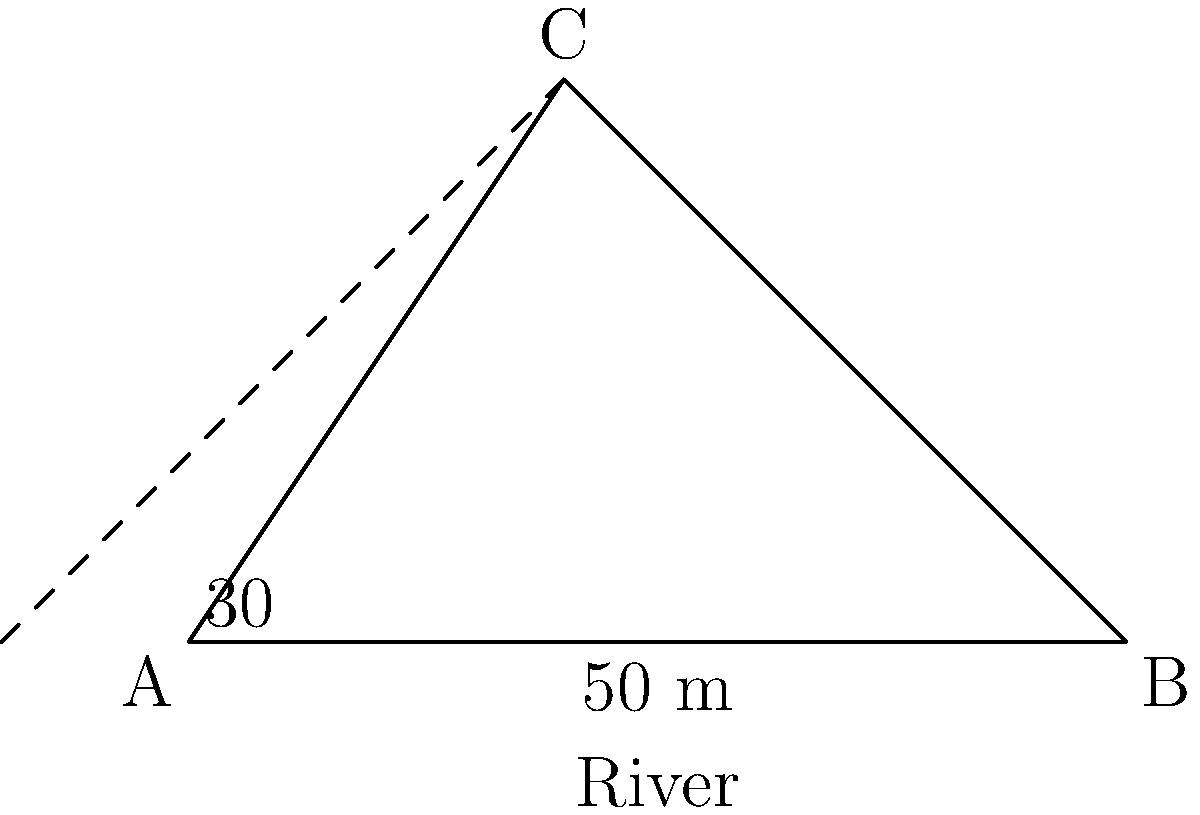During a nature hike, you come across a wide river. You want to sketch the landscape, including the river's width. Using your artistic skills, you set up a simple triangulation method. You stand at point A and see a tree on the opposite bank at point C. You walk 50 meters along the riverbank to point B. The angle between your original line of sight (AC) and the riverbank (AB) is 30°. At point B, you measure the angle between BC and BA to be 60°. How wide is the river? Let's solve this step-by-step:

1) We have a triangle ABC, where:
   - AB is 50 meters (the distance you walked)
   - Angle BAC is 30°
   - Angle ABC is 60°

2) We can find the third angle of the triangle:
   $180° - (30° + 60°) = 90°$
   So, angle BCA is 90°. This is a right-angled triangle.

3) In a right-angled triangle, we can use trigonometric ratios. We want to find AC, which is opposite to the 60° angle.

4) We can use the sine ratio:
   $\sin(60°) = \frac{AC}{AB}$

5) Rearranging this:
   $AC = AB \times \sin(60°)$

6) We know AB = 50 m, and $\sin(60°) = \frac{\sqrt{3}}{2}$

7) Substituting these values:
   $AC = 50 \times \frac{\sqrt{3}}{2} = 25\sqrt{3}$ meters

Therefore, the width of the river is $25\sqrt{3}$ meters.
Answer: $25\sqrt{3}$ meters 